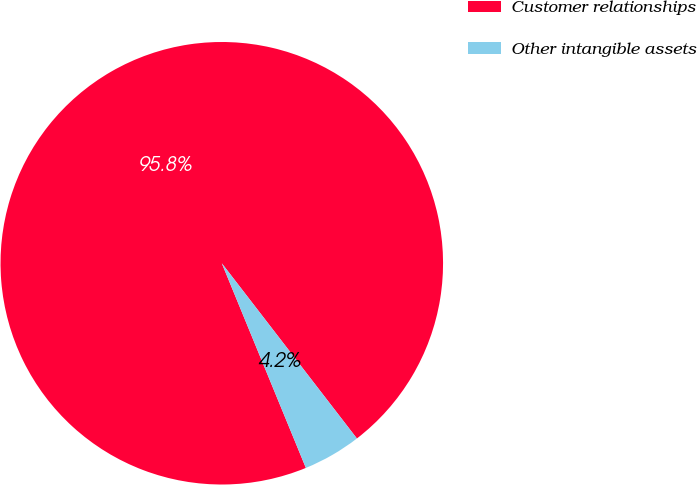Convert chart. <chart><loc_0><loc_0><loc_500><loc_500><pie_chart><fcel>Customer relationships<fcel>Other intangible assets<nl><fcel>95.75%<fcel>4.25%<nl></chart> 